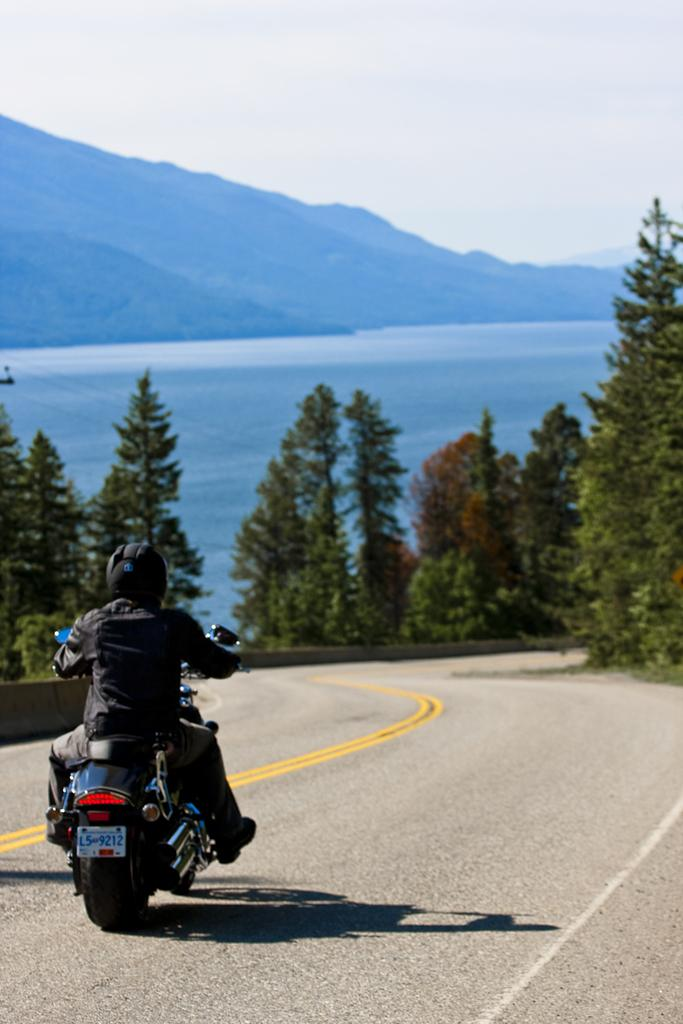What is the main subject of the image? There is a person riding a motorcycle in the image. Where is the motorcycle located? The motorcycle is on a road. What can be seen in the background of the image? There are trees, the sea, hills, and the sky visible in the background of the image. What type of church can be seen in the background of the image? There is no church present in the image; the background features trees, the sea, hills, and the sky. 